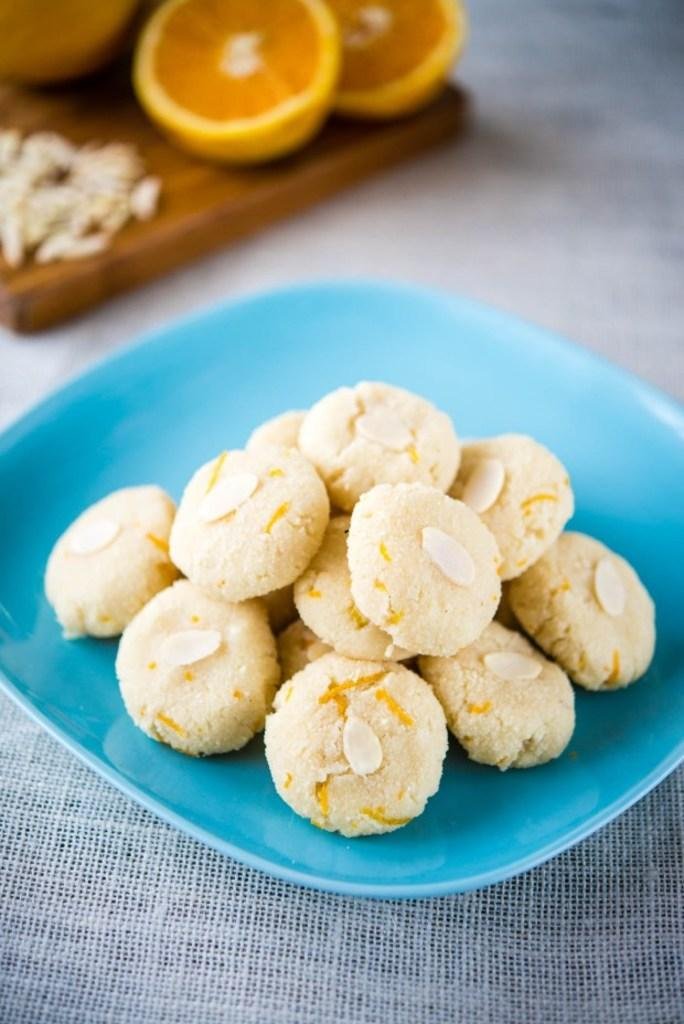What is the main object in the center of the image? There is a blue color plate in the center of the image. What is on the blue color plate? Biscuits are present on the blue color plate. What type of object is at the top of the image? There are fruits on a wooden object at the top of the image. What is the object at the bottom of the image? There is a mesh-like object at the bottom of the image. What type of development can be seen happening in the image? There is no development or construction activity visible in the image. What type of cream is being used to decorate the biscuits in the image? There is no cream or frosting visible on the biscuits in the image. 